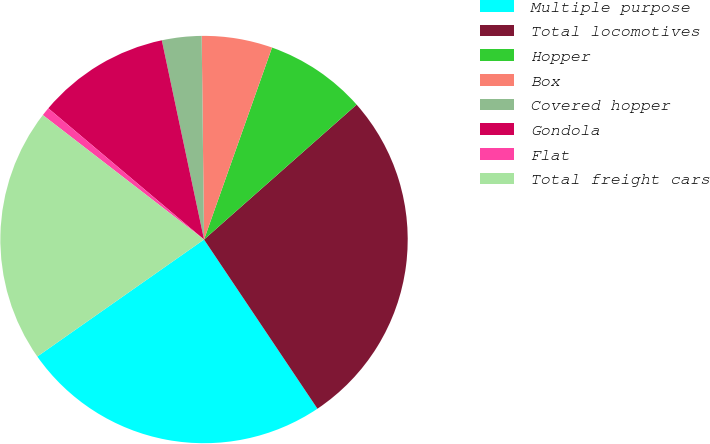Convert chart. <chart><loc_0><loc_0><loc_500><loc_500><pie_chart><fcel>Multiple purpose<fcel>Total locomotives<fcel>Hopper<fcel>Box<fcel>Covered hopper<fcel>Gondola<fcel>Flat<fcel>Total freight cars<nl><fcel>24.66%<fcel>27.12%<fcel>8.06%<fcel>5.6%<fcel>3.14%<fcel>10.53%<fcel>0.68%<fcel>20.2%<nl></chart> 